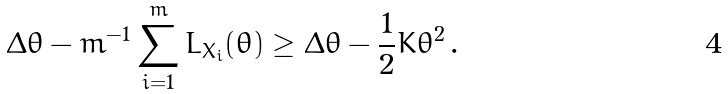<formula> <loc_0><loc_0><loc_500><loc_500>\Delta \theta - m ^ { - 1 } \sum _ { i = 1 } ^ { m } L _ { X _ { i } } ( \theta ) \geq \Delta \theta - \frac { 1 } { 2 } K \theta ^ { 2 } \, .</formula> 